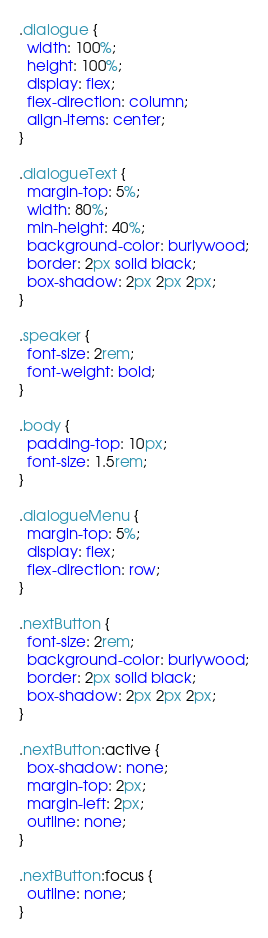<code> <loc_0><loc_0><loc_500><loc_500><_CSS_>.dialogue {
  width: 100%;
  height: 100%;
  display: flex;
  flex-direction: column;
  align-items: center;
}

.dialogueText {
  margin-top: 5%;
  width: 80%;
  min-height: 40%;
  background-color: burlywood;
  border: 2px solid black;
  box-shadow: 2px 2px 2px;
}

.speaker {
  font-size: 2rem;
  font-weight: bold;
}

.body {
  padding-top: 10px;
  font-size: 1.5rem;
}

.dialogueMenu {
  margin-top: 5%;
  display: flex;
  flex-direction: row;
}

.nextButton {
  font-size: 2rem;
  background-color: burlywood;
  border: 2px solid black;
  box-shadow: 2px 2px 2px;
}

.nextButton:active {
  box-shadow: none;
  margin-top: 2px;
  margin-left: 2px;
  outline: none;
}

.nextButton:focus {
  outline: none;
}</code> 